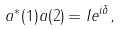<formula> <loc_0><loc_0><loc_500><loc_500>a ^ { * } ( 1 ) a ( 2 ) = I e ^ { i \delta } ,</formula> 